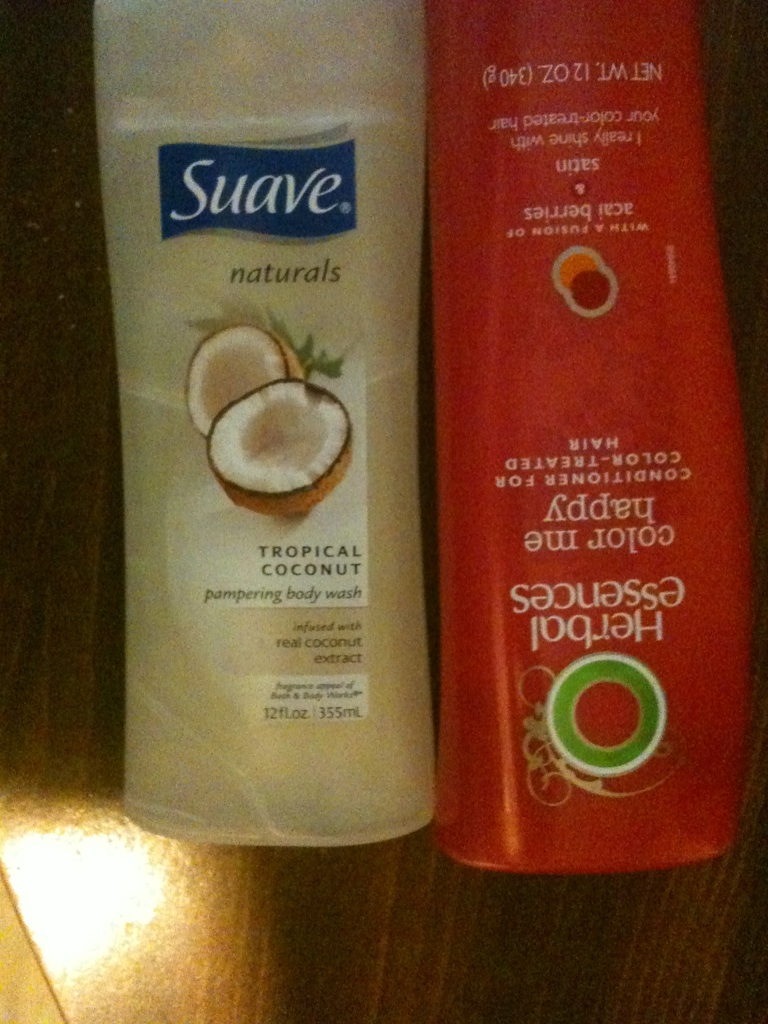Can you provide a brief description of the products in these bottles? Certainly! The product on the left is Suave Tropical Coconut Pampering Body Wash, known for its coconut scent and skin pampering properties. The product on the right is Herbal Essences Color Me Happy Conditioner, which helps to maintain and enhance the vibrancy of color-treated hair. 